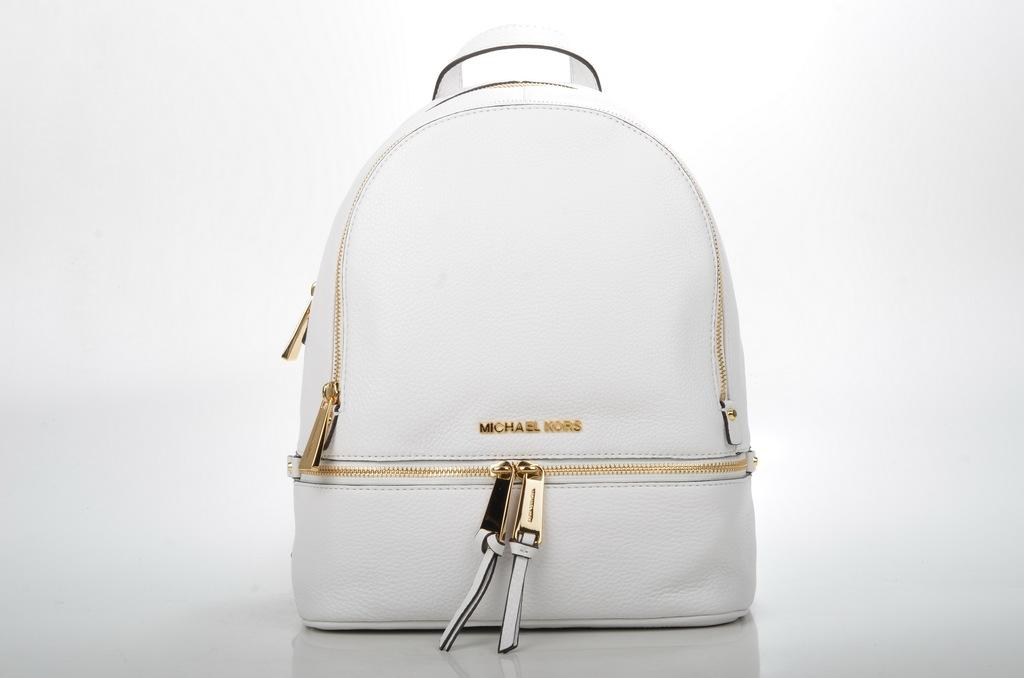What type of bag is visible in the image? There is a white bag in the image. What additional feature can be seen on the white bag? The white bag has gold zips. How does the bag help in the learning process in the image? The image does not show any learning process or context, so it is not possible to determine how the bag might be involved in learning. 